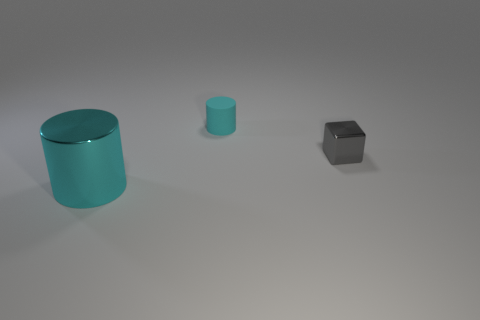Add 3 small gray shiny cubes. How many objects exist? 6 Subtract all blocks. How many objects are left? 2 Subtract 0 brown balls. How many objects are left? 3 Subtract all cylinders. Subtract all big gray things. How many objects are left? 1 Add 1 cylinders. How many cylinders are left? 3 Add 2 large green metallic spheres. How many large green metallic spheres exist? 2 